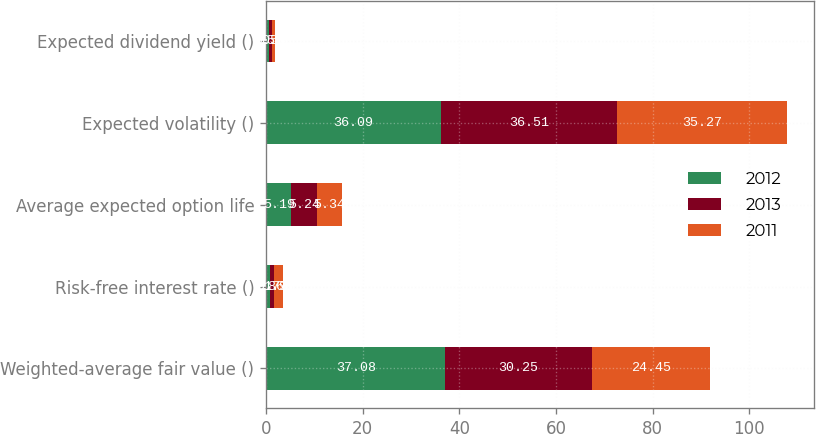Convert chart to OTSL. <chart><loc_0><loc_0><loc_500><loc_500><stacked_bar_chart><ecel><fcel>Weighted-average fair value ()<fcel>Risk-free interest rate ()<fcel>Average expected option life<fcel>Expected volatility ()<fcel>Expected dividend yield ()<nl><fcel>2012<fcel>37.08<fcel>0.86<fcel>5.19<fcel>36.09<fcel>0.56<nl><fcel>2013<fcel>30.25<fcel>0.77<fcel>5.24<fcel>36.51<fcel>0.58<nl><fcel>2011<fcel>24.45<fcel>1.91<fcel>5.34<fcel>35.27<fcel>0.6<nl></chart> 